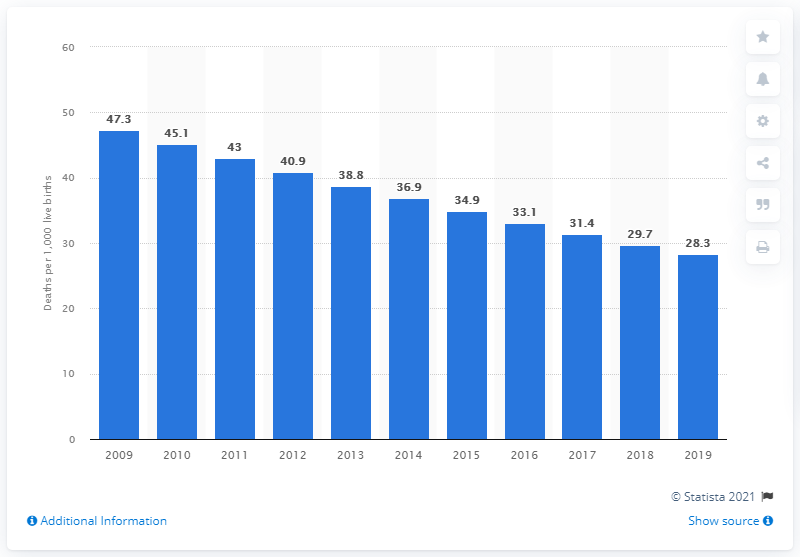Draw attention to some important aspects in this diagram. In 2019, the infant mortality rate in India was 28.3 deaths per 1,000 live births. 